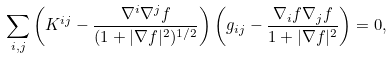<formula> <loc_0><loc_0><loc_500><loc_500>\sum _ { i , j } \left ( K ^ { i j } - \frac { \nabla ^ { i } \nabla ^ { j } f } { ( 1 + | \nabla f | ^ { 2 } ) ^ { 1 / 2 } } \right ) \left ( g _ { i j } - \frac { \nabla _ { i } f \nabla _ { j } f } { 1 + | \nabla f | ^ { 2 } } \right ) = 0 ,</formula> 